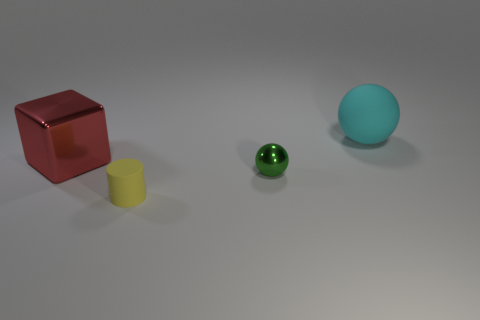The cylinder has what color?
Give a very brief answer. Yellow. There is a small metallic object that is the same shape as the cyan rubber thing; what color is it?
Your answer should be very brief. Green. How many green metal objects have the same shape as the cyan object?
Your response must be concise. 1. What number of objects are either small green shiny spheres or objects that are to the right of the yellow rubber thing?
Provide a short and direct response. 2. Do the tiny matte cylinder and the metal thing to the right of the tiny rubber cylinder have the same color?
Your response must be concise. No. What is the size of the object that is both right of the red shiny object and behind the small sphere?
Offer a very short reply. Large. There is a green metallic sphere; are there any red cubes right of it?
Your response must be concise. No. Are there any small green objects to the right of the metallic thing that is on the right side of the yellow thing?
Keep it short and to the point. No. Is the number of large matte spheres that are on the left side of the large red metallic cube the same as the number of big cyan things right of the cylinder?
Offer a terse response. No. What is the color of the tiny thing that is made of the same material as the large red cube?
Keep it short and to the point. Green. 